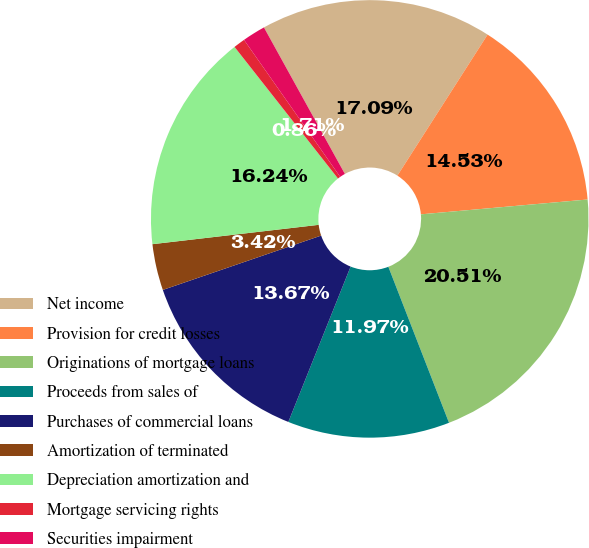<chart> <loc_0><loc_0><loc_500><loc_500><pie_chart><fcel>Net income<fcel>Provision for credit losses<fcel>Originations of mortgage loans<fcel>Proceeds from sales of<fcel>Purchases of commercial loans<fcel>Amortization of terminated<fcel>Depreciation amortization and<fcel>Mortgage servicing rights<fcel>Securities impairment<nl><fcel>17.09%<fcel>14.53%<fcel>20.51%<fcel>11.97%<fcel>13.67%<fcel>3.42%<fcel>16.24%<fcel>0.86%<fcel>1.71%<nl></chart> 